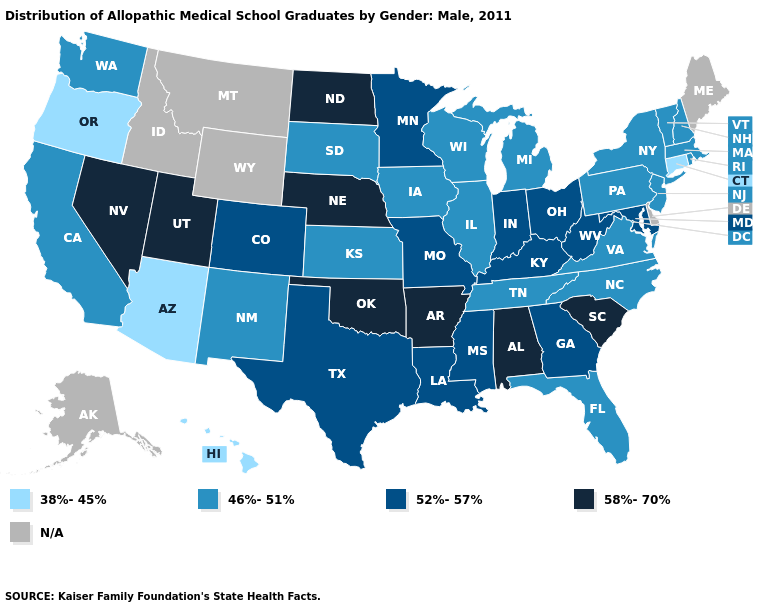What is the value of Georgia?
Be succinct. 52%-57%. Does Connecticut have the lowest value in the Northeast?
Concise answer only. Yes. What is the highest value in the USA?
Quick response, please. 58%-70%. Among the states that border Louisiana , which have the highest value?
Concise answer only. Arkansas. What is the lowest value in the Northeast?
Give a very brief answer. 38%-45%. What is the value of Arkansas?
Quick response, please. 58%-70%. Among the states that border Wyoming , which have the lowest value?
Answer briefly. South Dakota. Name the states that have a value in the range 52%-57%?
Be succinct. Colorado, Georgia, Indiana, Kentucky, Louisiana, Maryland, Minnesota, Mississippi, Missouri, Ohio, Texas, West Virginia. What is the value of Illinois?
Give a very brief answer. 46%-51%. Name the states that have a value in the range N/A?
Be succinct. Alaska, Delaware, Idaho, Maine, Montana, Wyoming. Does Connecticut have the lowest value in the USA?
Be succinct. Yes. Name the states that have a value in the range 46%-51%?
Give a very brief answer. California, Florida, Illinois, Iowa, Kansas, Massachusetts, Michigan, New Hampshire, New Jersey, New Mexico, New York, North Carolina, Pennsylvania, Rhode Island, South Dakota, Tennessee, Vermont, Virginia, Washington, Wisconsin. Name the states that have a value in the range 38%-45%?
Concise answer only. Arizona, Connecticut, Hawaii, Oregon. 